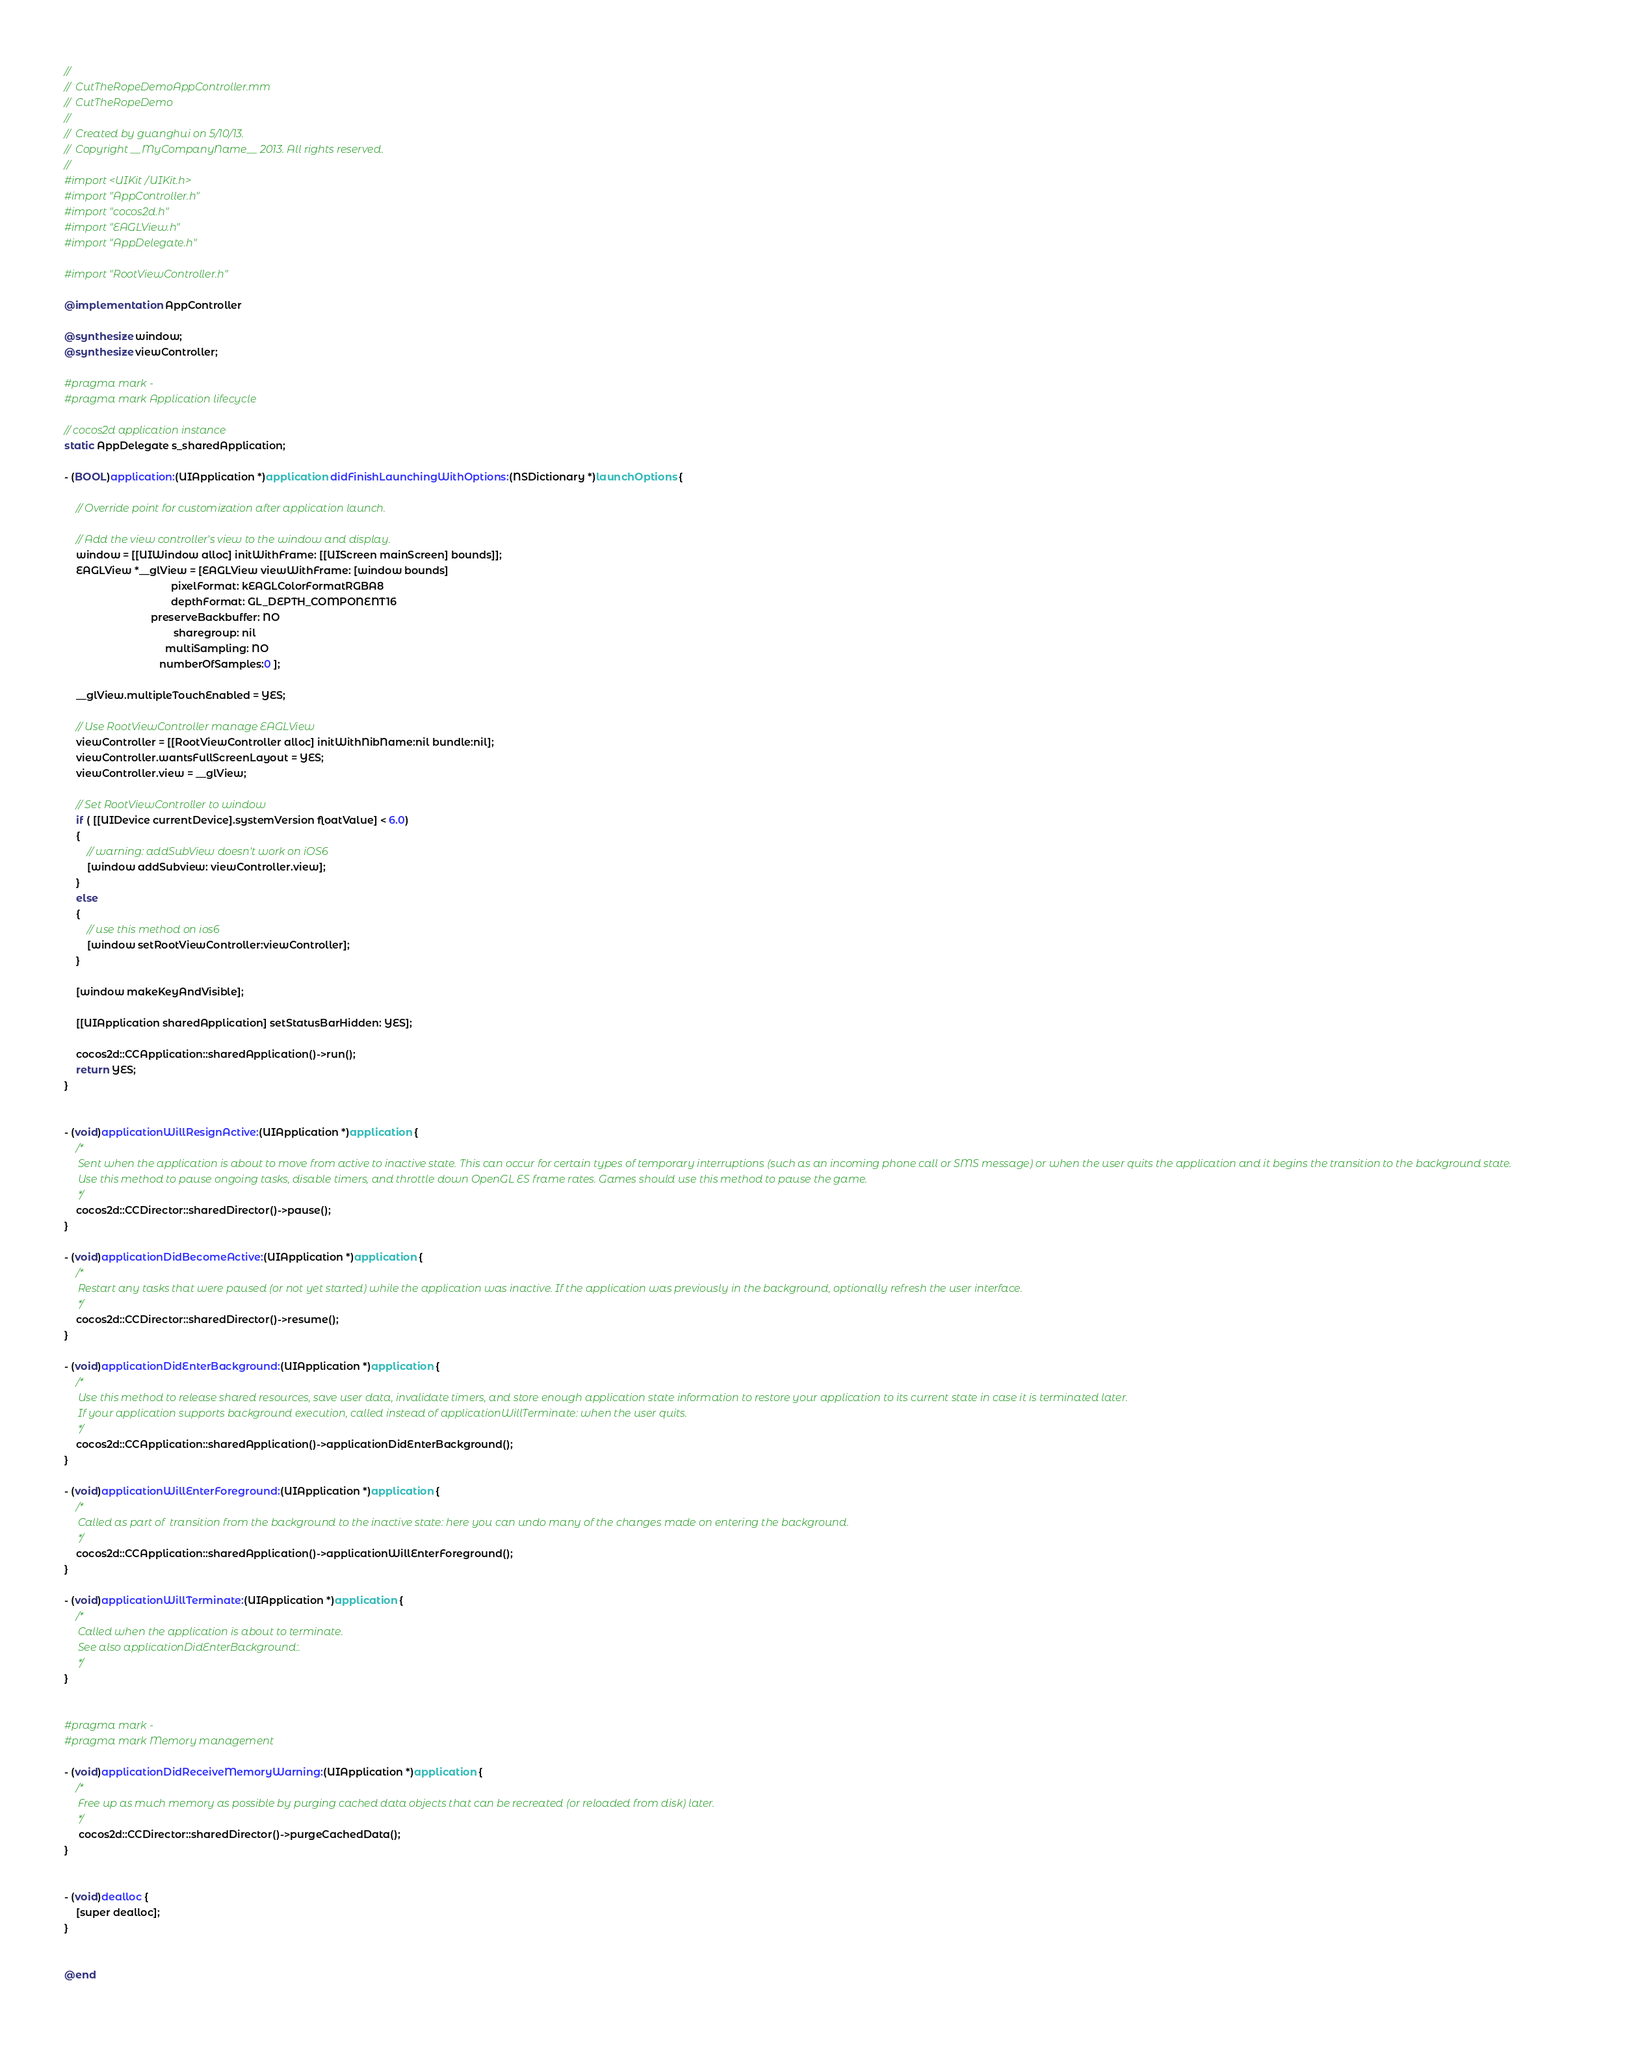<code> <loc_0><loc_0><loc_500><loc_500><_ObjectiveC_>//
//  CutTheRopeDemoAppController.mm
//  CutTheRopeDemo
//
//  Created by guanghui on 5/10/13.
//  Copyright __MyCompanyName__ 2013. All rights reserved.
//
#import <UIKit/UIKit.h>
#import "AppController.h"
#import "cocos2d.h"
#import "EAGLView.h"
#import "AppDelegate.h"

#import "RootViewController.h"

@implementation AppController

@synthesize window;
@synthesize viewController;

#pragma mark -
#pragma mark Application lifecycle

// cocos2d application instance
static AppDelegate s_sharedApplication;

- (BOOL)application:(UIApplication *)application didFinishLaunchingWithOptions:(NSDictionary *)launchOptions {

    // Override point for customization after application launch.

    // Add the view controller's view to the window and display.
    window = [[UIWindow alloc] initWithFrame: [[UIScreen mainScreen] bounds]];
    EAGLView *__glView = [EAGLView viewWithFrame: [window bounds]
                                     pixelFormat: kEAGLColorFormatRGBA8
                                     depthFormat: GL_DEPTH_COMPONENT16
                              preserveBackbuffer: NO
                                      sharegroup: nil
                                   multiSampling: NO
                                 numberOfSamples:0 ];
    
    __glView.multipleTouchEnabled = YES;

    // Use RootViewController manage EAGLView
    viewController = [[RootViewController alloc] initWithNibName:nil bundle:nil];
    viewController.wantsFullScreenLayout = YES;
    viewController.view = __glView;

    // Set RootViewController to window
    if ( [[UIDevice currentDevice].systemVersion floatValue] < 6.0)
    {
        // warning: addSubView doesn't work on iOS6
        [window addSubview: viewController.view];
    }
    else
    {
        // use this method on ios6
        [window setRootViewController:viewController];
    }
    
    [window makeKeyAndVisible];

    [[UIApplication sharedApplication] setStatusBarHidden: YES];

    cocos2d::CCApplication::sharedApplication()->run();
    return YES;
}


- (void)applicationWillResignActive:(UIApplication *)application {
    /*
     Sent when the application is about to move from active to inactive state. This can occur for certain types of temporary interruptions (such as an incoming phone call or SMS message) or when the user quits the application and it begins the transition to the background state.
     Use this method to pause ongoing tasks, disable timers, and throttle down OpenGL ES frame rates. Games should use this method to pause the game.
     */
    cocos2d::CCDirector::sharedDirector()->pause();
}

- (void)applicationDidBecomeActive:(UIApplication *)application {
    /*
     Restart any tasks that were paused (or not yet started) while the application was inactive. If the application was previously in the background, optionally refresh the user interface.
     */
    cocos2d::CCDirector::sharedDirector()->resume();
}

- (void)applicationDidEnterBackground:(UIApplication *)application {
    /*
     Use this method to release shared resources, save user data, invalidate timers, and store enough application state information to restore your application to its current state in case it is terminated later.
     If your application supports background execution, called instead of applicationWillTerminate: when the user quits.
     */
    cocos2d::CCApplication::sharedApplication()->applicationDidEnterBackground();
}

- (void)applicationWillEnterForeground:(UIApplication *)application {
    /*
     Called as part of  transition from the background to the inactive state: here you can undo many of the changes made on entering the background.
     */
    cocos2d::CCApplication::sharedApplication()->applicationWillEnterForeground();
}

- (void)applicationWillTerminate:(UIApplication *)application {
    /*
     Called when the application is about to terminate.
     See also applicationDidEnterBackground:.
     */
}


#pragma mark -
#pragma mark Memory management

- (void)applicationDidReceiveMemoryWarning:(UIApplication *)application {
    /*
     Free up as much memory as possible by purging cached data objects that can be recreated (or reloaded from disk) later.
     */
     cocos2d::CCDirector::sharedDirector()->purgeCachedData();
}


- (void)dealloc {
    [super dealloc];
}


@end

</code> 